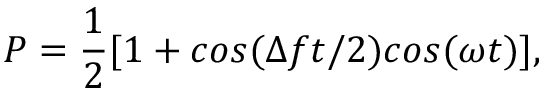<formula> <loc_0><loc_0><loc_500><loc_500>P = \frac { 1 } { 2 } [ 1 + \cos ( \Delta f t / 2 ) \cos ( \omega t ) ] ,</formula> 